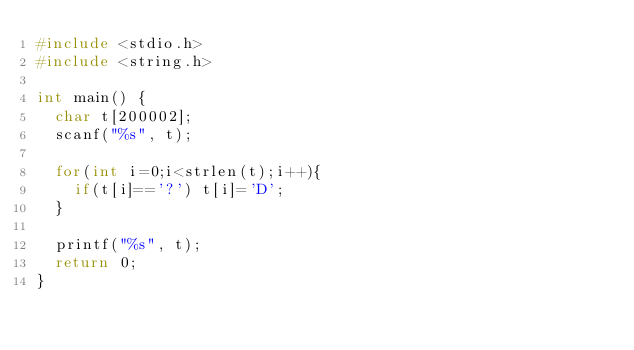<code> <loc_0><loc_0><loc_500><loc_500><_C_>#include <stdio.h>
#include <string.h>

int main() {
  char t[200002];
  scanf("%s", t);

  for(int i=0;i<strlen(t);i++){
    if(t[i]=='?') t[i]='D';
  }

  printf("%s", t);
  return 0;
}
</code> 